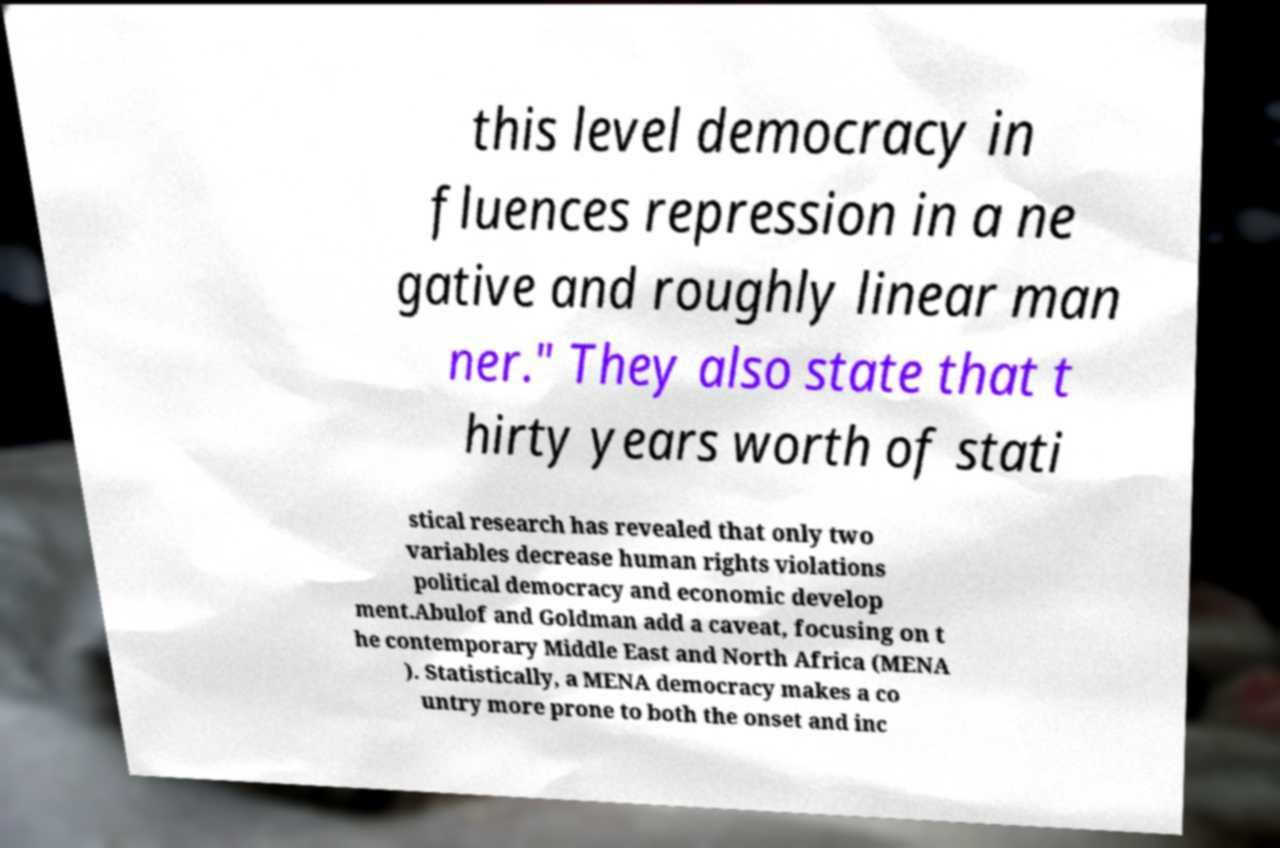Can you read and provide the text displayed in the image?This photo seems to have some interesting text. Can you extract and type it out for me? this level democracy in fluences repression in a ne gative and roughly linear man ner." They also state that t hirty years worth of stati stical research has revealed that only two variables decrease human rights violations political democracy and economic develop ment.Abulof and Goldman add a caveat, focusing on t he contemporary Middle East and North Africa (MENA ). Statistically, a MENA democracy makes a co untry more prone to both the onset and inc 